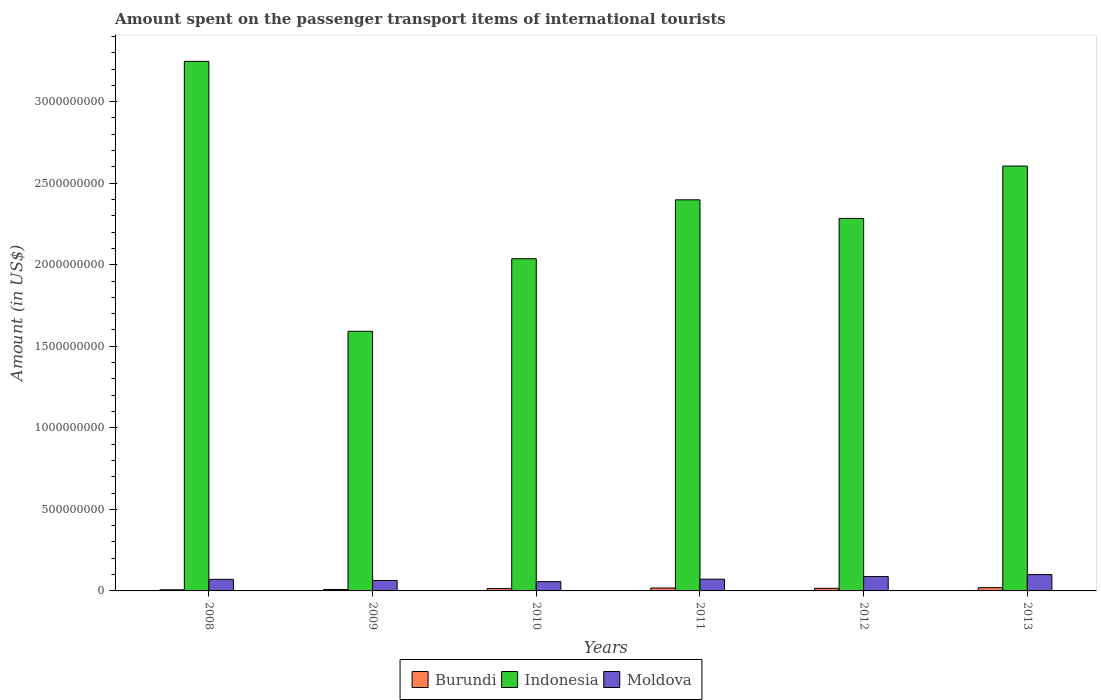How many different coloured bars are there?
Make the answer very short. 3. How many groups of bars are there?
Keep it short and to the point. 6. Are the number of bars on each tick of the X-axis equal?
Keep it short and to the point. Yes. What is the label of the 3rd group of bars from the left?
Ensure brevity in your answer.  2010. In how many cases, is the number of bars for a given year not equal to the number of legend labels?
Keep it short and to the point. 0. What is the amount spent on the passenger transport items of international tourists in Burundi in 2010?
Ensure brevity in your answer.  1.50e+07. Across all years, what is the maximum amount spent on the passenger transport items of international tourists in Indonesia?
Your answer should be compact. 3.25e+09. Across all years, what is the minimum amount spent on the passenger transport items of international tourists in Indonesia?
Your answer should be compact. 1.59e+09. What is the total amount spent on the passenger transport items of international tourists in Indonesia in the graph?
Offer a very short reply. 1.42e+1. What is the difference between the amount spent on the passenger transport items of international tourists in Moldova in 2008 and that in 2013?
Give a very brief answer. -2.90e+07. What is the difference between the amount spent on the passenger transport items of international tourists in Indonesia in 2008 and the amount spent on the passenger transport items of international tourists in Moldova in 2010?
Your answer should be compact. 3.19e+09. What is the average amount spent on the passenger transport items of international tourists in Burundi per year?
Provide a succinct answer. 1.42e+07. In the year 2013, what is the difference between the amount spent on the passenger transport items of international tourists in Moldova and amount spent on the passenger transport items of international tourists in Burundi?
Provide a short and direct response. 8.00e+07. In how many years, is the amount spent on the passenger transport items of international tourists in Moldova greater than 1600000000 US$?
Your answer should be compact. 0. What is the ratio of the amount spent on the passenger transport items of international tourists in Indonesia in 2010 to that in 2012?
Provide a succinct answer. 0.89. Is the difference between the amount spent on the passenger transport items of international tourists in Moldova in 2012 and 2013 greater than the difference between the amount spent on the passenger transport items of international tourists in Burundi in 2012 and 2013?
Your answer should be very brief. No. What is the difference between the highest and the second highest amount spent on the passenger transport items of international tourists in Burundi?
Your answer should be very brief. 2.00e+06. What is the difference between the highest and the lowest amount spent on the passenger transport items of international tourists in Moldova?
Keep it short and to the point. 4.30e+07. In how many years, is the amount spent on the passenger transport items of international tourists in Indonesia greater than the average amount spent on the passenger transport items of international tourists in Indonesia taken over all years?
Provide a short and direct response. 3. What does the 3rd bar from the left in 2013 represents?
Offer a very short reply. Moldova. What does the 3rd bar from the right in 2011 represents?
Keep it short and to the point. Burundi. Are all the bars in the graph horizontal?
Give a very brief answer. No. How many years are there in the graph?
Provide a succinct answer. 6. What is the difference between two consecutive major ticks on the Y-axis?
Your answer should be compact. 5.00e+08. Are the values on the major ticks of Y-axis written in scientific E-notation?
Offer a very short reply. No. Does the graph contain any zero values?
Provide a short and direct response. No. Does the graph contain grids?
Your response must be concise. No. Where does the legend appear in the graph?
Offer a terse response. Bottom center. How many legend labels are there?
Provide a short and direct response. 3. What is the title of the graph?
Ensure brevity in your answer.  Amount spent on the passenger transport items of international tourists. What is the label or title of the X-axis?
Provide a succinct answer. Years. What is the label or title of the Y-axis?
Provide a succinct answer. Amount (in US$). What is the Amount (in US$) in Burundi in 2008?
Your answer should be very brief. 7.00e+06. What is the Amount (in US$) in Indonesia in 2008?
Make the answer very short. 3.25e+09. What is the Amount (in US$) of Moldova in 2008?
Your answer should be compact. 7.10e+07. What is the Amount (in US$) in Burundi in 2009?
Your answer should be very brief. 9.00e+06. What is the Amount (in US$) of Indonesia in 2009?
Your answer should be compact. 1.59e+09. What is the Amount (in US$) in Moldova in 2009?
Your answer should be compact. 6.40e+07. What is the Amount (in US$) of Burundi in 2010?
Give a very brief answer. 1.50e+07. What is the Amount (in US$) in Indonesia in 2010?
Give a very brief answer. 2.04e+09. What is the Amount (in US$) of Moldova in 2010?
Make the answer very short. 5.70e+07. What is the Amount (in US$) in Burundi in 2011?
Make the answer very short. 1.80e+07. What is the Amount (in US$) in Indonesia in 2011?
Offer a very short reply. 2.40e+09. What is the Amount (in US$) of Moldova in 2011?
Offer a terse response. 7.20e+07. What is the Amount (in US$) in Burundi in 2012?
Provide a succinct answer. 1.60e+07. What is the Amount (in US$) of Indonesia in 2012?
Give a very brief answer. 2.28e+09. What is the Amount (in US$) in Moldova in 2012?
Provide a succinct answer. 8.80e+07. What is the Amount (in US$) in Indonesia in 2013?
Provide a short and direct response. 2.60e+09. What is the Amount (in US$) in Moldova in 2013?
Offer a terse response. 1.00e+08. Across all years, what is the maximum Amount (in US$) in Indonesia?
Your answer should be very brief. 3.25e+09. Across all years, what is the minimum Amount (in US$) of Burundi?
Offer a very short reply. 7.00e+06. Across all years, what is the minimum Amount (in US$) in Indonesia?
Your answer should be compact. 1.59e+09. Across all years, what is the minimum Amount (in US$) of Moldova?
Keep it short and to the point. 5.70e+07. What is the total Amount (in US$) of Burundi in the graph?
Keep it short and to the point. 8.50e+07. What is the total Amount (in US$) of Indonesia in the graph?
Your answer should be compact. 1.42e+1. What is the total Amount (in US$) of Moldova in the graph?
Make the answer very short. 4.52e+08. What is the difference between the Amount (in US$) of Indonesia in 2008 and that in 2009?
Offer a terse response. 1.66e+09. What is the difference between the Amount (in US$) in Moldova in 2008 and that in 2009?
Ensure brevity in your answer.  7.00e+06. What is the difference between the Amount (in US$) of Burundi in 2008 and that in 2010?
Your answer should be compact. -8.00e+06. What is the difference between the Amount (in US$) of Indonesia in 2008 and that in 2010?
Ensure brevity in your answer.  1.21e+09. What is the difference between the Amount (in US$) in Moldova in 2008 and that in 2010?
Your answer should be very brief. 1.40e+07. What is the difference between the Amount (in US$) of Burundi in 2008 and that in 2011?
Offer a very short reply. -1.10e+07. What is the difference between the Amount (in US$) of Indonesia in 2008 and that in 2011?
Ensure brevity in your answer.  8.49e+08. What is the difference between the Amount (in US$) of Burundi in 2008 and that in 2012?
Keep it short and to the point. -9.00e+06. What is the difference between the Amount (in US$) of Indonesia in 2008 and that in 2012?
Your response must be concise. 9.63e+08. What is the difference between the Amount (in US$) of Moldova in 2008 and that in 2012?
Keep it short and to the point. -1.70e+07. What is the difference between the Amount (in US$) in Burundi in 2008 and that in 2013?
Offer a very short reply. -1.30e+07. What is the difference between the Amount (in US$) of Indonesia in 2008 and that in 2013?
Make the answer very short. 6.42e+08. What is the difference between the Amount (in US$) of Moldova in 2008 and that in 2013?
Provide a short and direct response. -2.90e+07. What is the difference between the Amount (in US$) in Burundi in 2009 and that in 2010?
Offer a terse response. -6.00e+06. What is the difference between the Amount (in US$) in Indonesia in 2009 and that in 2010?
Give a very brief answer. -4.45e+08. What is the difference between the Amount (in US$) in Burundi in 2009 and that in 2011?
Ensure brevity in your answer.  -9.00e+06. What is the difference between the Amount (in US$) in Indonesia in 2009 and that in 2011?
Offer a very short reply. -8.06e+08. What is the difference between the Amount (in US$) of Moldova in 2009 and that in 2011?
Give a very brief answer. -8.00e+06. What is the difference between the Amount (in US$) in Burundi in 2009 and that in 2012?
Offer a terse response. -7.00e+06. What is the difference between the Amount (in US$) of Indonesia in 2009 and that in 2012?
Offer a terse response. -6.92e+08. What is the difference between the Amount (in US$) of Moldova in 2009 and that in 2012?
Provide a short and direct response. -2.40e+07. What is the difference between the Amount (in US$) of Burundi in 2009 and that in 2013?
Your response must be concise. -1.10e+07. What is the difference between the Amount (in US$) in Indonesia in 2009 and that in 2013?
Give a very brief answer. -1.01e+09. What is the difference between the Amount (in US$) in Moldova in 2009 and that in 2013?
Your answer should be very brief. -3.60e+07. What is the difference between the Amount (in US$) of Indonesia in 2010 and that in 2011?
Your answer should be very brief. -3.61e+08. What is the difference between the Amount (in US$) of Moldova in 2010 and that in 2011?
Ensure brevity in your answer.  -1.50e+07. What is the difference between the Amount (in US$) in Burundi in 2010 and that in 2012?
Offer a terse response. -1.00e+06. What is the difference between the Amount (in US$) of Indonesia in 2010 and that in 2012?
Keep it short and to the point. -2.47e+08. What is the difference between the Amount (in US$) of Moldova in 2010 and that in 2012?
Provide a short and direct response. -3.10e+07. What is the difference between the Amount (in US$) in Burundi in 2010 and that in 2013?
Offer a very short reply. -5.00e+06. What is the difference between the Amount (in US$) of Indonesia in 2010 and that in 2013?
Provide a short and direct response. -5.68e+08. What is the difference between the Amount (in US$) in Moldova in 2010 and that in 2013?
Your answer should be very brief. -4.30e+07. What is the difference between the Amount (in US$) of Burundi in 2011 and that in 2012?
Your answer should be very brief. 2.00e+06. What is the difference between the Amount (in US$) in Indonesia in 2011 and that in 2012?
Your answer should be compact. 1.14e+08. What is the difference between the Amount (in US$) of Moldova in 2011 and that in 2012?
Give a very brief answer. -1.60e+07. What is the difference between the Amount (in US$) of Indonesia in 2011 and that in 2013?
Your answer should be very brief. -2.07e+08. What is the difference between the Amount (in US$) in Moldova in 2011 and that in 2013?
Keep it short and to the point. -2.80e+07. What is the difference between the Amount (in US$) of Indonesia in 2012 and that in 2013?
Make the answer very short. -3.21e+08. What is the difference between the Amount (in US$) in Moldova in 2012 and that in 2013?
Give a very brief answer. -1.20e+07. What is the difference between the Amount (in US$) in Burundi in 2008 and the Amount (in US$) in Indonesia in 2009?
Give a very brief answer. -1.58e+09. What is the difference between the Amount (in US$) in Burundi in 2008 and the Amount (in US$) in Moldova in 2009?
Your answer should be compact. -5.70e+07. What is the difference between the Amount (in US$) of Indonesia in 2008 and the Amount (in US$) of Moldova in 2009?
Provide a succinct answer. 3.18e+09. What is the difference between the Amount (in US$) in Burundi in 2008 and the Amount (in US$) in Indonesia in 2010?
Your answer should be very brief. -2.03e+09. What is the difference between the Amount (in US$) in Burundi in 2008 and the Amount (in US$) in Moldova in 2010?
Give a very brief answer. -5.00e+07. What is the difference between the Amount (in US$) in Indonesia in 2008 and the Amount (in US$) in Moldova in 2010?
Offer a very short reply. 3.19e+09. What is the difference between the Amount (in US$) in Burundi in 2008 and the Amount (in US$) in Indonesia in 2011?
Your response must be concise. -2.39e+09. What is the difference between the Amount (in US$) in Burundi in 2008 and the Amount (in US$) in Moldova in 2011?
Make the answer very short. -6.50e+07. What is the difference between the Amount (in US$) of Indonesia in 2008 and the Amount (in US$) of Moldova in 2011?
Keep it short and to the point. 3.18e+09. What is the difference between the Amount (in US$) in Burundi in 2008 and the Amount (in US$) in Indonesia in 2012?
Your answer should be very brief. -2.28e+09. What is the difference between the Amount (in US$) in Burundi in 2008 and the Amount (in US$) in Moldova in 2012?
Your answer should be compact. -8.10e+07. What is the difference between the Amount (in US$) of Indonesia in 2008 and the Amount (in US$) of Moldova in 2012?
Your answer should be compact. 3.16e+09. What is the difference between the Amount (in US$) of Burundi in 2008 and the Amount (in US$) of Indonesia in 2013?
Keep it short and to the point. -2.60e+09. What is the difference between the Amount (in US$) in Burundi in 2008 and the Amount (in US$) in Moldova in 2013?
Your response must be concise. -9.30e+07. What is the difference between the Amount (in US$) of Indonesia in 2008 and the Amount (in US$) of Moldova in 2013?
Give a very brief answer. 3.15e+09. What is the difference between the Amount (in US$) in Burundi in 2009 and the Amount (in US$) in Indonesia in 2010?
Provide a succinct answer. -2.03e+09. What is the difference between the Amount (in US$) of Burundi in 2009 and the Amount (in US$) of Moldova in 2010?
Give a very brief answer. -4.80e+07. What is the difference between the Amount (in US$) in Indonesia in 2009 and the Amount (in US$) in Moldova in 2010?
Provide a succinct answer. 1.54e+09. What is the difference between the Amount (in US$) in Burundi in 2009 and the Amount (in US$) in Indonesia in 2011?
Your answer should be very brief. -2.39e+09. What is the difference between the Amount (in US$) of Burundi in 2009 and the Amount (in US$) of Moldova in 2011?
Your response must be concise. -6.30e+07. What is the difference between the Amount (in US$) of Indonesia in 2009 and the Amount (in US$) of Moldova in 2011?
Make the answer very short. 1.52e+09. What is the difference between the Amount (in US$) in Burundi in 2009 and the Amount (in US$) in Indonesia in 2012?
Your answer should be very brief. -2.28e+09. What is the difference between the Amount (in US$) of Burundi in 2009 and the Amount (in US$) of Moldova in 2012?
Offer a very short reply. -7.90e+07. What is the difference between the Amount (in US$) of Indonesia in 2009 and the Amount (in US$) of Moldova in 2012?
Offer a terse response. 1.50e+09. What is the difference between the Amount (in US$) of Burundi in 2009 and the Amount (in US$) of Indonesia in 2013?
Give a very brief answer. -2.60e+09. What is the difference between the Amount (in US$) in Burundi in 2009 and the Amount (in US$) in Moldova in 2013?
Give a very brief answer. -9.10e+07. What is the difference between the Amount (in US$) of Indonesia in 2009 and the Amount (in US$) of Moldova in 2013?
Give a very brief answer. 1.49e+09. What is the difference between the Amount (in US$) in Burundi in 2010 and the Amount (in US$) in Indonesia in 2011?
Ensure brevity in your answer.  -2.38e+09. What is the difference between the Amount (in US$) of Burundi in 2010 and the Amount (in US$) of Moldova in 2011?
Your answer should be compact. -5.70e+07. What is the difference between the Amount (in US$) of Indonesia in 2010 and the Amount (in US$) of Moldova in 2011?
Ensure brevity in your answer.  1.96e+09. What is the difference between the Amount (in US$) of Burundi in 2010 and the Amount (in US$) of Indonesia in 2012?
Your response must be concise. -2.27e+09. What is the difference between the Amount (in US$) in Burundi in 2010 and the Amount (in US$) in Moldova in 2012?
Your answer should be compact. -7.30e+07. What is the difference between the Amount (in US$) of Indonesia in 2010 and the Amount (in US$) of Moldova in 2012?
Ensure brevity in your answer.  1.95e+09. What is the difference between the Amount (in US$) of Burundi in 2010 and the Amount (in US$) of Indonesia in 2013?
Your answer should be compact. -2.59e+09. What is the difference between the Amount (in US$) in Burundi in 2010 and the Amount (in US$) in Moldova in 2013?
Your answer should be compact. -8.50e+07. What is the difference between the Amount (in US$) of Indonesia in 2010 and the Amount (in US$) of Moldova in 2013?
Provide a short and direct response. 1.94e+09. What is the difference between the Amount (in US$) in Burundi in 2011 and the Amount (in US$) in Indonesia in 2012?
Your answer should be compact. -2.27e+09. What is the difference between the Amount (in US$) of Burundi in 2011 and the Amount (in US$) of Moldova in 2012?
Your response must be concise. -7.00e+07. What is the difference between the Amount (in US$) of Indonesia in 2011 and the Amount (in US$) of Moldova in 2012?
Offer a terse response. 2.31e+09. What is the difference between the Amount (in US$) in Burundi in 2011 and the Amount (in US$) in Indonesia in 2013?
Keep it short and to the point. -2.59e+09. What is the difference between the Amount (in US$) of Burundi in 2011 and the Amount (in US$) of Moldova in 2013?
Give a very brief answer. -8.20e+07. What is the difference between the Amount (in US$) of Indonesia in 2011 and the Amount (in US$) of Moldova in 2013?
Keep it short and to the point. 2.30e+09. What is the difference between the Amount (in US$) of Burundi in 2012 and the Amount (in US$) of Indonesia in 2013?
Your answer should be very brief. -2.59e+09. What is the difference between the Amount (in US$) of Burundi in 2012 and the Amount (in US$) of Moldova in 2013?
Offer a very short reply. -8.40e+07. What is the difference between the Amount (in US$) of Indonesia in 2012 and the Amount (in US$) of Moldova in 2013?
Give a very brief answer. 2.18e+09. What is the average Amount (in US$) of Burundi per year?
Ensure brevity in your answer.  1.42e+07. What is the average Amount (in US$) in Indonesia per year?
Offer a very short reply. 2.36e+09. What is the average Amount (in US$) of Moldova per year?
Your answer should be compact. 7.53e+07. In the year 2008, what is the difference between the Amount (in US$) in Burundi and Amount (in US$) in Indonesia?
Provide a succinct answer. -3.24e+09. In the year 2008, what is the difference between the Amount (in US$) of Burundi and Amount (in US$) of Moldova?
Offer a very short reply. -6.40e+07. In the year 2008, what is the difference between the Amount (in US$) in Indonesia and Amount (in US$) in Moldova?
Provide a short and direct response. 3.18e+09. In the year 2009, what is the difference between the Amount (in US$) of Burundi and Amount (in US$) of Indonesia?
Keep it short and to the point. -1.58e+09. In the year 2009, what is the difference between the Amount (in US$) of Burundi and Amount (in US$) of Moldova?
Provide a succinct answer. -5.50e+07. In the year 2009, what is the difference between the Amount (in US$) of Indonesia and Amount (in US$) of Moldova?
Offer a very short reply. 1.53e+09. In the year 2010, what is the difference between the Amount (in US$) of Burundi and Amount (in US$) of Indonesia?
Give a very brief answer. -2.02e+09. In the year 2010, what is the difference between the Amount (in US$) in Burundi and Amount (in US$) in Moldova?
Make the answer very short. -4.20e+07. In the year 2010, what is the difference between the Amount (in US$) in Indonesia and Amount (in US$) in Moldova?
Make the answer very short. 1.98e+09. In the year 2011, what is the difference between the Amount (in US$) in Burundi and Amount (in US$) in Indonesia?
Your answer should be very brief. -2.38e+09. In the year 2011, what is the difference between the Amount (in US$) of Burundi and Amount (in US$) of Moldova?
Your response must be concise. -5.40e+07. In the year 2011, what is the difference between the Amount (in US$) in Indonesia and Amount (in US$) in Moldova?
Your response must be concise. 2.33e+09. In the year 2012, what is the difference between the Amount (in US$) of Burundi and Amount (in US$) of Indonesia?
Make the answer very short. -2.27e+09. In the year 2012, what is the difference between the Amount (in US$) in Burundi and Amount (in US$) in Moldova?
Offer a very short reply. -7.20e+07. In the year 2012, what is the difference between the Amount (in US$) in Indonesia and Amount (in US$) in Moldova?
Make the answer very short. 2.20e+09. In the year 2013, what is the difference between the Amount (in US$) in Burundi and Amount (in US$) in Indonesia?
Your answer should be very brief. -2.58e+09. In the year 2013, what is the difference between the Amount (in US$) of Burundi and Amount (in US$) of Moldova?
Your answer should be very brief. -8.00e+07. In the year 2013, what is the difference between the Amount (in US$) in Indonesia and Amount (in US$) in Moldova?
Give a very brief answer. 2.50e+09. What is the ratio of the Amount (in US$) of Burundi in 2008 to that in 2009?
Your answer should be compact. 0.78. What is the ratio of the Amount (in US$) in Indonesia in 2008 to that in 2009?
Your answer should be compact. 2.04. What is the ratio of the Amount (in US$) of Moldova in 2008 to that in 2009?
Give a very brief answer. 1.11. What is the ratio of the Amount (in US$) of Burundi in 2008 to that in 2010?
Provide a succinct answer. 0.47. What is the ratio of the Amount (in US$) in Indonesia in 2008 to that in 2010?
Offer a terse response. 1.59. What is the ratio of the Amount (in US$) of Moldova in 2008 to that in 2010?
Offer a very short reply. 1.25. What is the ratio of the Amount (in US$) in Burundi in 2008 to that in 2011?
Provide a succinct answer. 0.39. What is the ratio of the Amount (in US$) of Indonesia in 2008 to that in 2011?
Your response must be concise. 1.35. What is the ratio of the Amount (in US$) of Moldova in 2008 to that in 2011?
Your answer should be compact. 0.99. What is the ratio of the Amount (in US$) in Burundi in 2008 to that in 2012?
Provide a succinct answer. 0.44. What is the ratio of the Amount (in US$) in Indonesia in 2008 to that in 2012?
Provide a short and direct response. 1.42. What is the ratio of the Amount (in US$) in Moldova in 2008 to that in 2012?
Offer a terse response. 0.81. What is the ratio of the Amount (in US$) in Indonesia in 2008 to that in 2013?
Keep it short and to the point. 1.25. What is the ratio of the Amount (in US$) of Moldova in 2008 to that in 2013?
Provide a succinct answer. 0.71. What is the ratio of the Amount (in US$) of Indonesia in 2009 to that in 2010?
Keep it short and to the point. 0.78. What is the ratio of the Amount (in US$) of Moldova in 2009 to that in 2010?
Make the answer very short. 1.12. What is the ratio of the Amount (in US$) in Indonesia in 2009 to that in 2011?
Ensure brevity in your answer.  0.66. What is the ratio of the Amount (in US$) of Moldova in 2009 to that in 2011?
Make the answer very short. 0.89. What is the ratio of the Amount (in US$) of Burundi in 2009 to that in 2012?
Give a very brief answer. 0.56. What is the ratio of the Amount (in US$) of Indonesia in 2009 to that in 2012?
Give a very brief answer. 0.7. What is the ratio of the Amount (in US$) in Moldova in 2009 to that in 2012?
Your answer should be compact. 0.73. What is the ratio of the Amount (in US$) in Burundi in 2009 to that in 2013?
Your answer should be compact. 0.45. What is the ratio of the Amount (in US$) of Indonesia in 2009 to that in 2013?
Your answer should be compact. 0.61. What is the ratio of the Amount (in US$) of Moldova in 2009 to that in 2013?
Make the answer very short. 0.64. What is the ratio of the Amount (in US$) of Indonesia in 2010 to that in 2011?
Keep it short and to the point. 0.85. What is the ratio of the Amount (in US$) in Moldova in 2010 to that in 2011?
Keep it short and to the point. 0.79. What is the ratio of the Amount (in US$) in Burundi in 2010 to that in 2012?
Provide a succinct answer. 0.94. What is the ratio of the Amount (in US$) in Indonesia in 2010 to that in 2012?
Offer a terse response. 0.89. What is the ratio of the Amount (in US$) in Moldova in 2010 to that in 2012?
Give a very brief answer. 0.65. What is the ratio of the Amount (in US$) of Burundi in 2010 to that in 2013?
Provide a short and direct response. 0.75. What is the ratio of the Amount (in US$) of Indonesia in 2010 to that in 2013?
Keep it short and to the point. 0.78. What is the ratio of the Amount (in US$) of Moldova in 2010 to that in 2013?
Offer a terse response. 0.57. What is the ratio of the Amount (in US$) in Indonesia in 2011 to that in 2012?
Keep it short and to the point. 1.05. What is the ratio of the Amount (in US$) in Moldova in 2011 to that in 2012?
Offer a terse response. 0.82. What is the ratio of the Amount (in US$) of Burundi in 2011 to that in 2013?
Provide a short and direct response. 0.9. What is the ratio of the Amount (in US$) in Indonesia in 2011 to that in 2013?
Your answer should be very brief. 0.92. What is the ratio of the Amount (in US$) of Moldova in 2011 to that in 2013?
Provide a short and direct response. 0.72. What is the ratio of the Amount (in US$) of Indonesia in 2012 to that in 2013?
Provide a short and direct response. 0.88. What is the difference between the highest and the second highest Amount (in US$) in Indonesia?
Provide a succinct answer. 6.42e+08. What is the difference between the highest and the second highest Amount (in US$) of Moldova?
Your response must be concise. 1.20e+07. What is the difference between the highest and the lowest Amount (in US$) in Burundi?
Provide a short and direct response. 1.30e+07. What is the difference between the highest and the lowest Amount (in US$) in Indonesia?
Offer a very short reply. 1.66e+09. What is the difference between the highest and the lowest Amount (in US$) of Moldova?
Provide a succinct answer. 4.30e+07. 